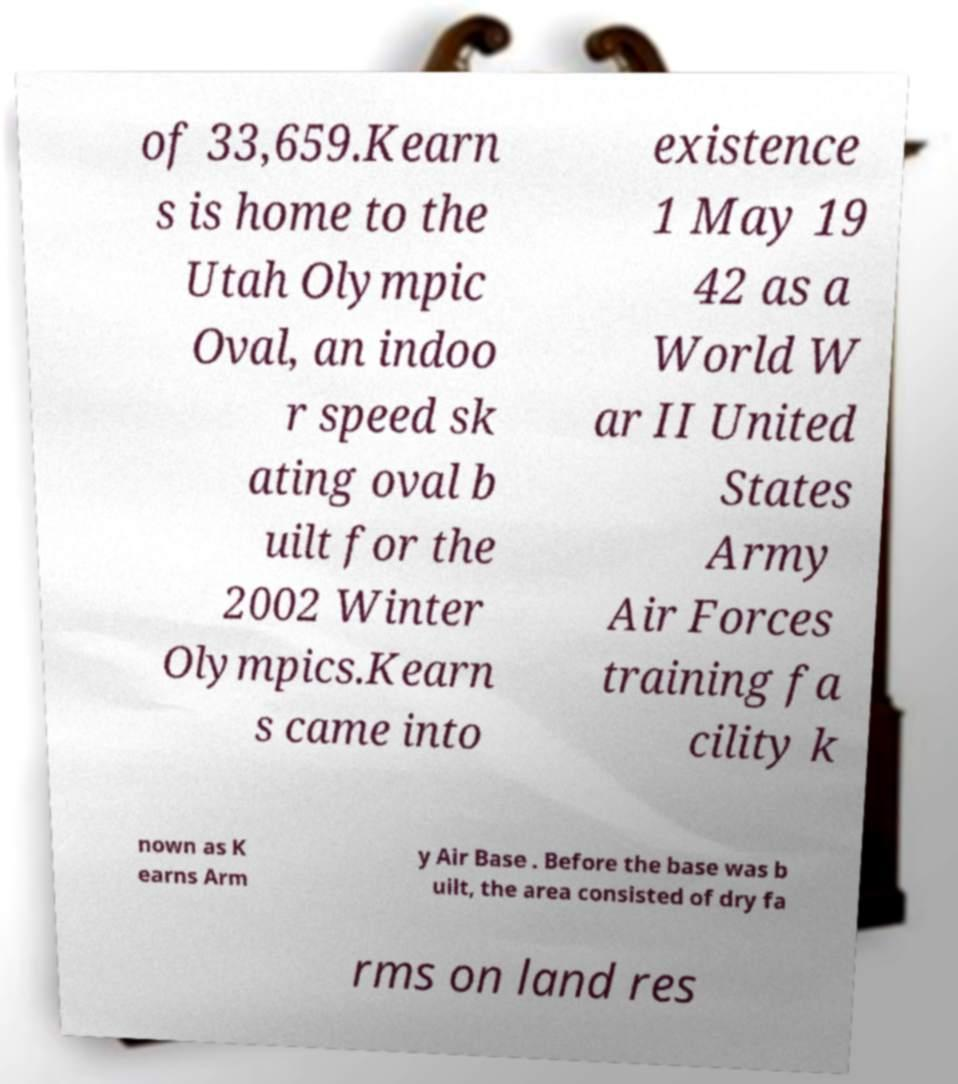What messages or text are displayed in this image? I need them in a readable, typed format. of 33,659.Kearn s is home to the Utah Olympic Oval, an indoo r speed sk ating oval b uilt for the 2002 Winter Olympics.Kearn s came into existence 1 May 19 42 as a World W ar II United States Army Air Forces training fa cility k nown as K earns Arm y Air Base . Before the base was b uilt, the area consisted of dry fa rms on land res 